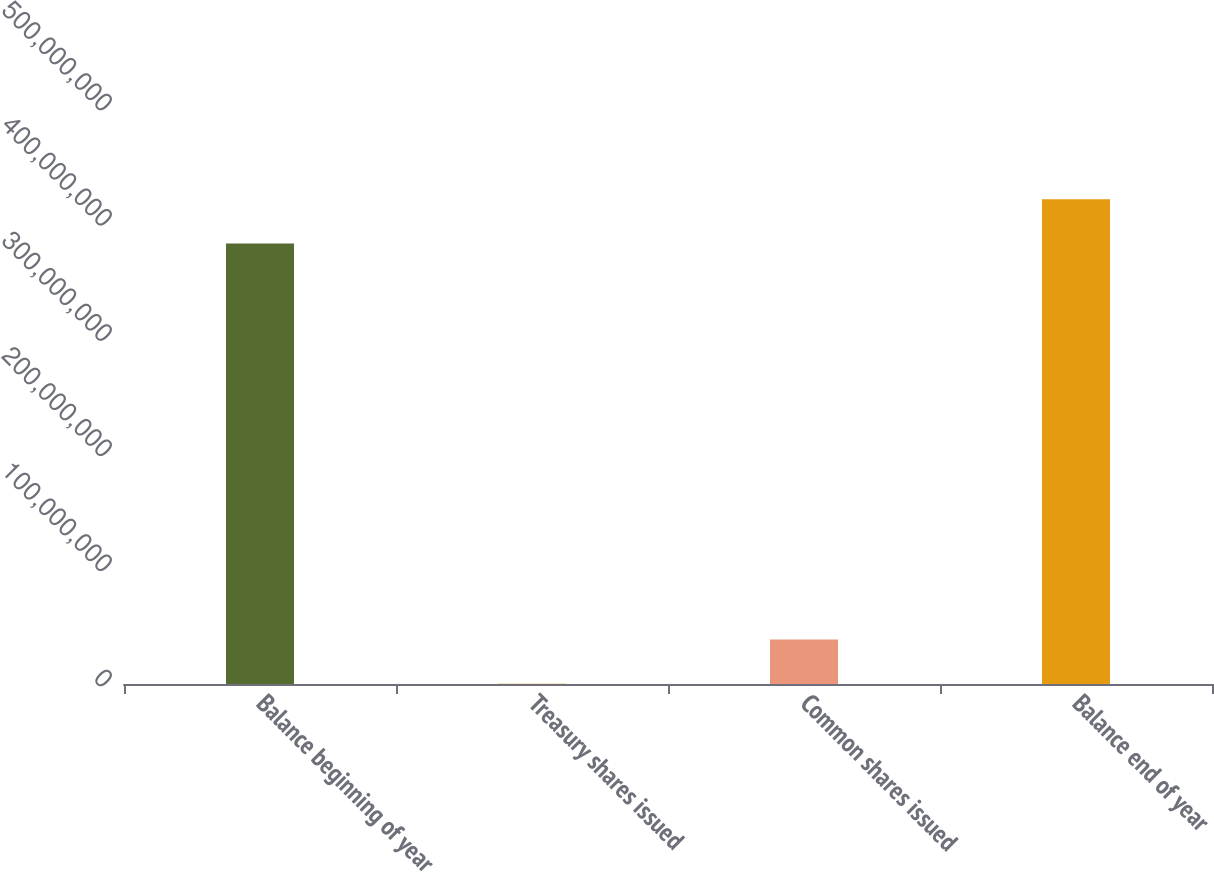<chart> <loc_0><loc_0><loc_500><loc_500><bar_chart><fcel>Balance beginning of year<fcel>Treasury shares issued<fcel>Common shares issued<fcel>Balance end of year<nl><fcel>3.82392e+08<fcel>144313<fcel>3.85416e+07<fcel>4.20789e+08<nl></chart> 